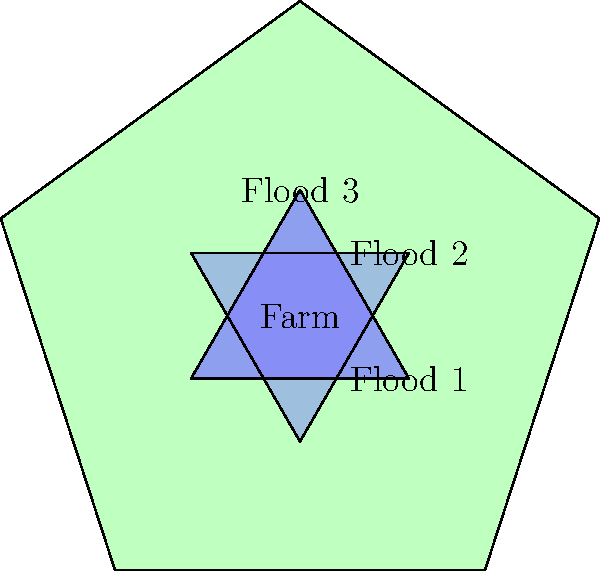A farmer's pentagonal field has been affected by three congruent triangular flood patterns, as shown in the diagram. If the total area of the farm is 100 acres and each flood pattern covers 15% of the farm's area, what is the total affected area in acres, considering the overlapping regions? To solve this problem, we need to use the principle of inclusion-exclusion for overlapping areas. Let's break it down step-by-step:

1. Calculate the area of each flood pattern:
   Each flood pattern covers 15% of the farm's area.
   Area of each flood = $0.15 \times 100 \text{ acres} = 15 \text{ acres}$

2. Calculate the total area of all three flood patterns without considering overlap:
   Total area = $3 \times 15 \text{ acres} = 45 \text{ acres}$

3. Identify the overlapping regions:
   There are three pairwise intersections and one triple intersection.

4. Calculate the area of each pairwise intersection:
   The flood patterns are congruent equilateral triangles rotated 60° from each other.
   The intersection of two equilateral triangles in this configuration is always $\frac{1}{3}$ of each triangle's area.
   Area of each pairwise intersection = $\frac{1}{3} \times 15 \text{ acres} = 5 \text{ acres}$

5. Calculate the area of the triple intersection:
   The triple intersection is the center of the three overlapping triangles.
   Its area is $\frac{1}{3}$ of the pairwise intersection area.
   Area of triple intersection = $\frac{1}{3} \times 5 \text{ acres} = \frac{5}{3} \text{ acres}$

6. Apply the inclusion-exclusion principle:
   Total affected area = Sum of individual areas - Sum of pairwise intersections + Triple intersection
   $= (15 + 15 + 15) - (5 + 5 + 5) + \frac{5}{3}$
   $= 45 - 15 + \frac{5}{3}$
   $= 30 + \frac{5}{3}$
   $= \frac{95}{3} \text{ acres}$

Therefore, the total affected area is $\frac{95}{3}$ or approximately 31.67 acres.
Answer: $\frac{95}{3}$ acres 